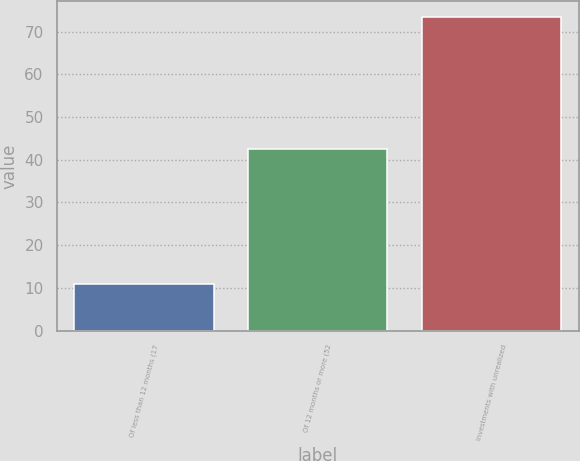<chart> <loc_0><loc_0><loc_500><loc_500><bar_chart><fcel>Of less than 12 months (17<fcel>Of 12 months or more (52<fcel>Investments with unrealized<nl><fcel>10.9<fcel>42.6<fcel>73.4<nl></chart> 